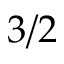<formula> <loc_0><loc_0><loc_500><loc_500>3 / 2</formula> 